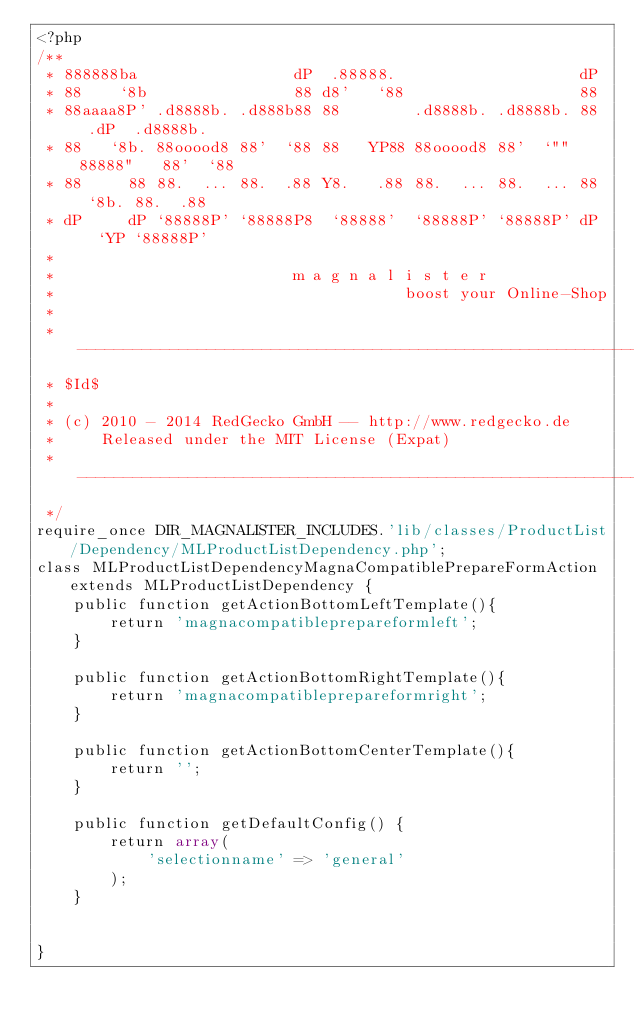Convert code to text. <code><loc_0><loc_0><loc_500><loc_500><_PHP_><?php
/**
 * 888888ba                 dP  .88888.                    dP                
 * 88    `8b                88 d8'   `88                   88                
 * 88aaaa8P' .d8888b. .d888b88 88        .d8888b. .d8888b. 88  .dP  .d8888b. 
 * 88   `8b. 88ooood8 88'  `88 88   YP88 88ooood8 88'  `"" 88888"   88'  `88 
 * 88     88 88.  ... 88.  .88 Y8.   .88 88.  ... 88.  ... 88  `8b. 88.  .88 
 * dP     dP `88888P' `88888P8  `88888'  `88888P' `88888P' dP   `YP `88888P' 
 *
 *                          m a g n a l i s t e r
 *                                      boost your Online-Shop
 *
 * -----------------------------------------------------------------------------
 * $Id$
 *
 * (c) 2010 - 2014 RedGecko GmbH -- http://www.redgecko.de
 *     Released under the MIT License (Expat)
 * -----------------------------------------------------------------------------
 */
require_once DIR_MAGNALISTER_INCLUDES.'lib/classes/ProductList/Dependency/MLProductListDependency.php';
class MLProductListDependencyMagnaCompatiblePrepareFormAction extends MLProductListDependency {
	public function getActionBottomLeftTemplate(){
		return 'magnacompatibleprepareformleft';
	}
	
	public function getActionBottomRightTemplate(){
		return 'magnacompatibleprepareformright';
	}
	
	public function getActionBottomCenterTemplate(){
		return '';
	}
	
	public function getDefaultConfig() {
		return array(
			'selectionname' => 'general'
		);
	}
	
	
}
</code> 